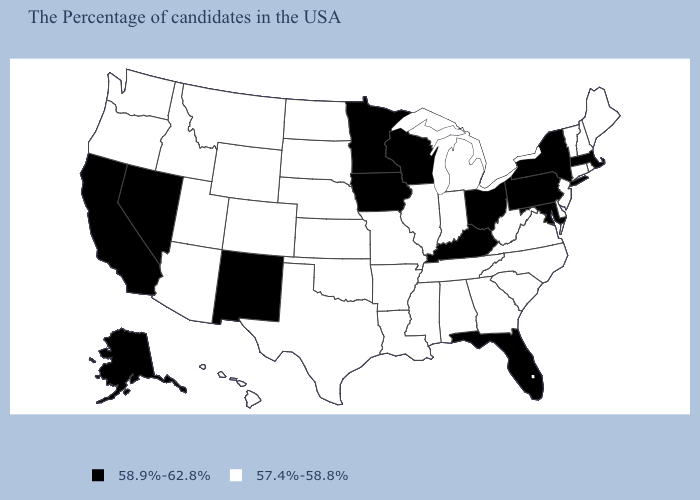What is the value of Nevada?
Answer briefly. 58.9%-62.8%. Does Florida have a lower value than Colorado?
Write a very short answer. No. Name the states that have a value in the range 57.4%-58.8%?
Concise answer only. Maine, Rhode Island, New Hampshire, Vermont, Connecticut, New Jersey, Delaware, Virginia, North Carolina, South Carolina, West Virginia, Georgia, Michigan, Indiana, Alabama, Tennessee, Illinois, Mississippi, Louisiana, Missouri, Arkansas, Kansas, Nebraska, Oklahoma, Texas, South Dakota, North Dakota, Wyoming, Colorado, Utah, Montana, Arizona, Idaho, Washington, Oregon, Hawaii. Name the states that have a value in the range 58.9%-62.8%?
Quick response, please. Massachusetts, New York, Maryland, Pennsylvania, Ohio, Florida, Kentucky, Wisconsin, Minnesota, Iowa, New Mexico, Nevada, California, Alaska. What is the value of Indiana?
Answer briefly. 57.4%-58.8%. Name the states that have a value in the range 57.4%-58.8%?
Answer briefly. Maine, Rhode Island, New Hampshire, Vermont, Connecticut, New Jersey, Delaware, Virginia, North Carolina, South Carolina, West Virginia, Georgia, Michigan, Indiana, Alabama, Tennessee, Illinois, Mississippi, Louisiana, Missouri, Arkansas, Kansas, Nebraska, Oklahoma, Texas, South Dakota, North Dakota, Wyoming, Colorado, Utah, Montana, Arizona, Idaho, Washington, Oregon, Hawaii. Name the states that have a value in the range 57.4%-58.8%?
Keep it brief. Maine, Rhode Island, New Hampshire, Vermont, Connecticut, New Jersey, Delaware, Virginia, North Carolina, South Carolina, West Virginia, Georgia, Michigan, Indiana, Alabama, Tennessee, Illinois, Mississippi, Louisiana, Missouri, Arkansas, Kansas, Nebraska, Oklahoma, Texas, South Dakota, North Dakota, Wyoming, Colorado, Utah, Montana, Arizona, Idaho, Washington, Oregon, Hawaii. Is the legend a continuous bar?
Quick response, please. No. What is the highest value in the Northeast ?
Concise answer only. 58.9%-62.8%. What is the value of Nebraska?
Give a very brief answer. 57.4%-58.8%. What is the value of Ohio?
Short answer required. 58.9%-62.8%. Does Wisconsin have the lowest value in the USA?
Be succinct. No. What is the highest value in the USA?
Be succinct. 58.9%-62.8%. What is the value of Washington?
Write a very short answer. 57.4%-58.8%. 